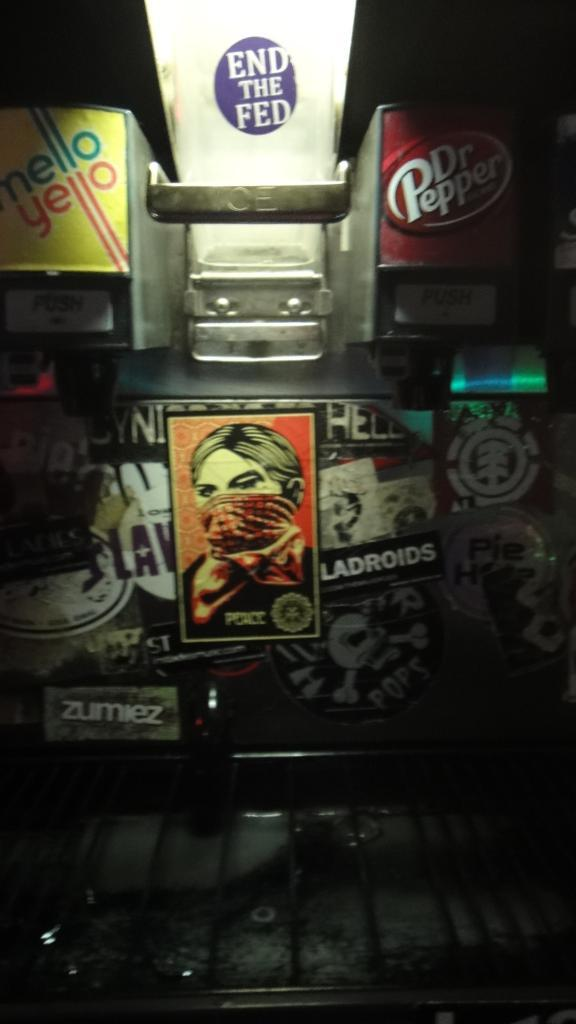<image>
Relay a brief, clear account of the picture shown. A soda fountain with many stickers on it that serves Dr Pepper and mello Yello 